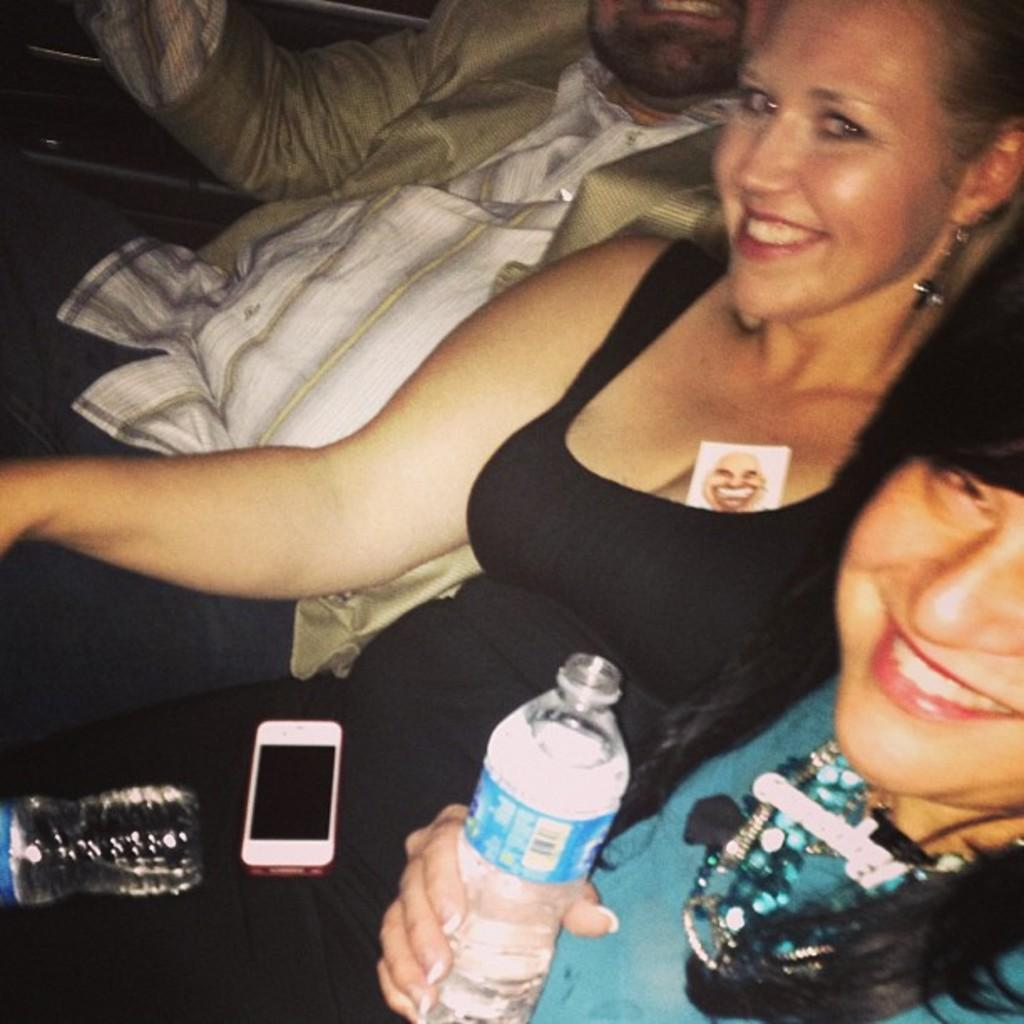How many people are in the image? There are three people in the image. Where are the people located in the image? The people are sitting inside a car. What is one of the people holding in the image? One of the people is holding a glass. What type of soda is the doctor recommending in the image? There is no doctor or soda present in the image. What effect does the car have on the people in the image? The car provides a mode of transportation for the people, but there is no specific effect mentioned in the image. 